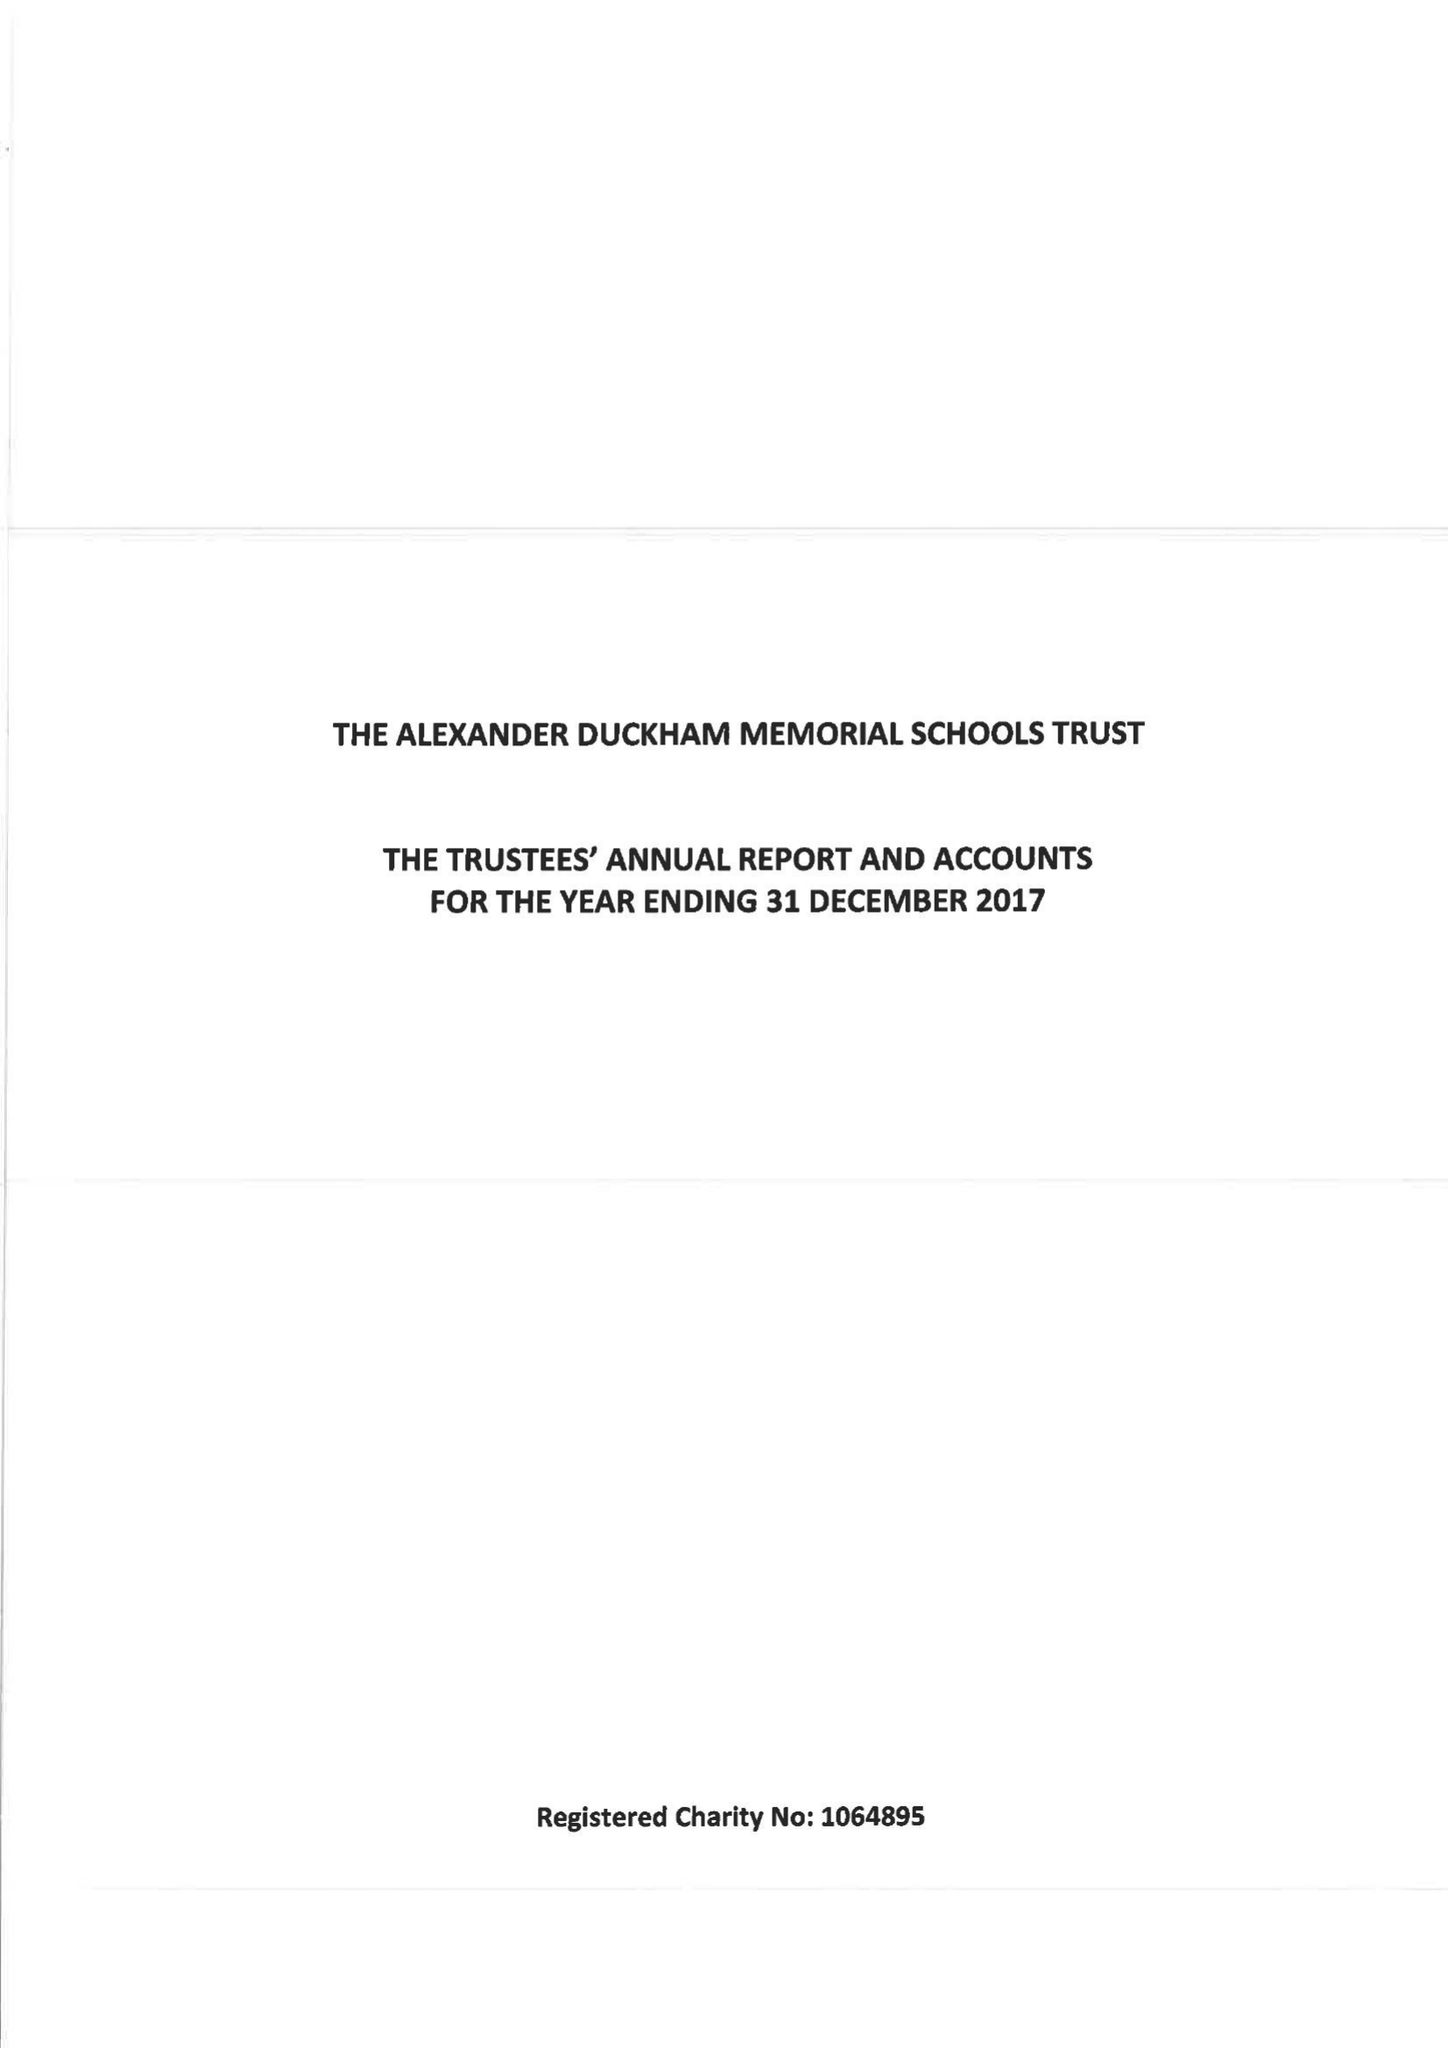What is the value for the address__post_town?
Answer the question using a single word or phrase. LONDON 